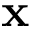Convert formula to latex. <formula><loc_0><loc_0><loc_500><loc_500>x</formula> 